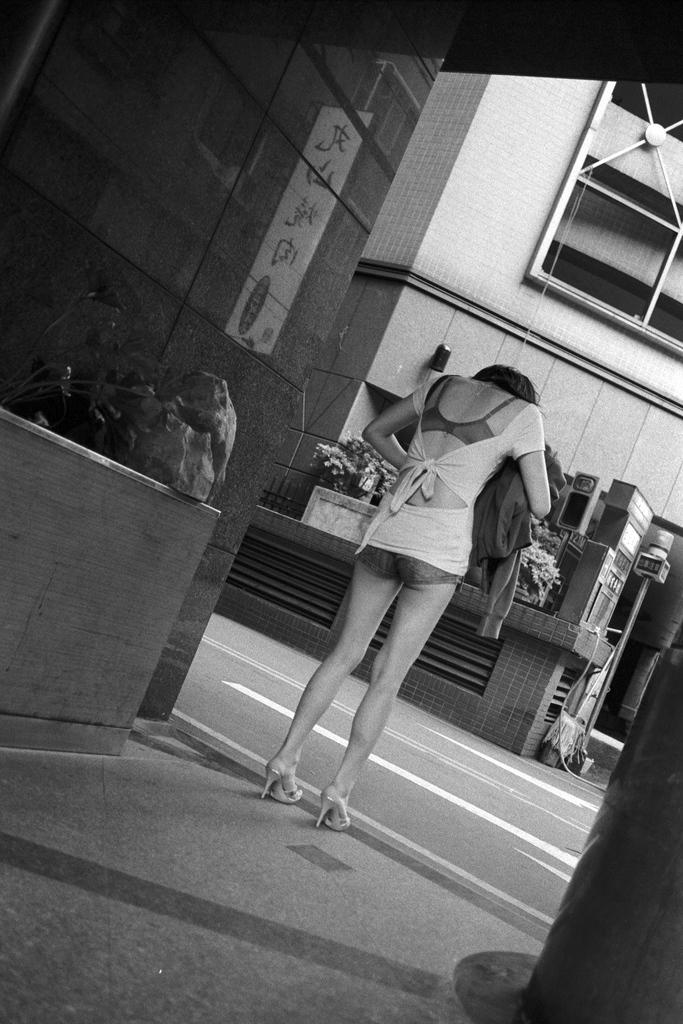Who is the main subject in the image? There is a lady in the center of the image. What is the lady holding in the image? The lady is holding a coat. What can be seen in the background of the image? There are flower pots and buildings visible in the background. What is at the bottom of the image? There is a road at the bottom of the image. What type of verse can be heard recited by the lady in the image? There is no indication in the image that the lady is reciting a verse, so it cannot be determined from the picture. 